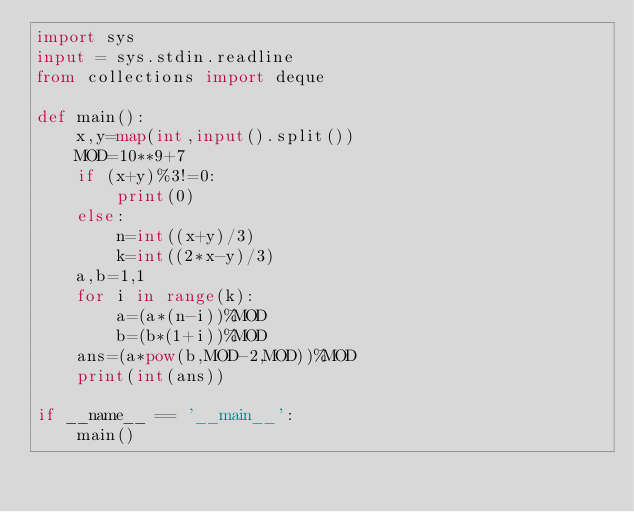<code> <loc_0><loc_0><loc_500><loc_500><_Python_>import sys
input = sys.stdin.readline
from collections import deque

def main():
    x,y=map(int,input().split())
    MOD=10**9+7
    if (x+y)%3!=0:
        print(0)
    else:
        n=int((x+y)/3)
        k=int((2*x-y)/3)
    a,b=1,1
    for i in range(k):
        a=(a*(n-i))%MOD
        b=(b*(1+i))%MOD
    ans=(a*pow(b,MOD-2,MOD))%MOD
    print(int(ans))
    
if __name__ == '__main__':
    main()</code> 